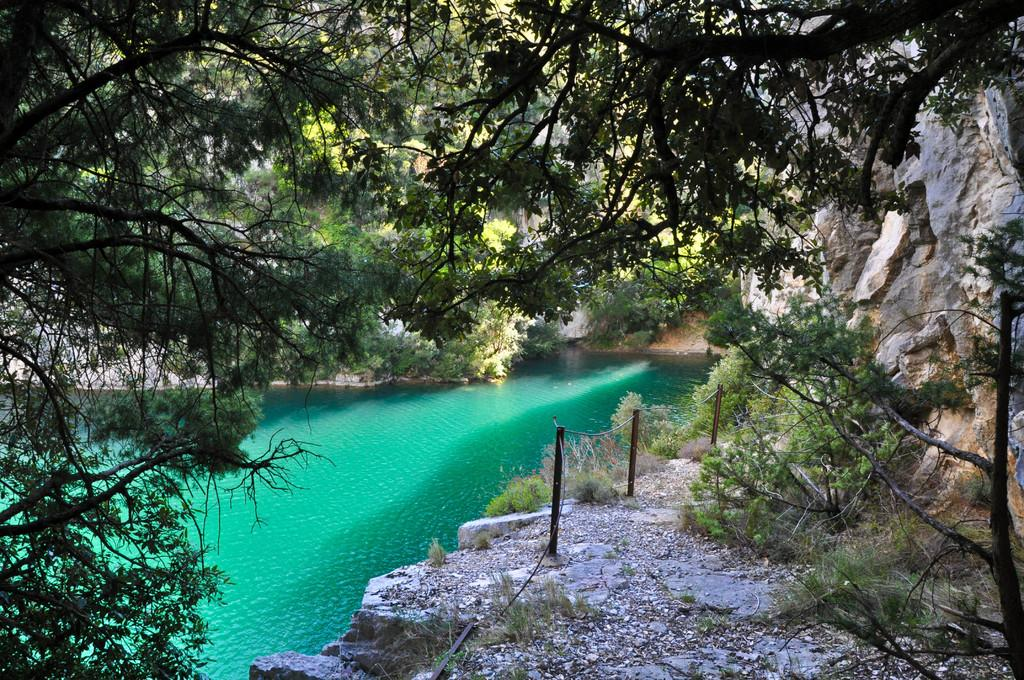What can be seen on the left side of the image? There is a pond on the left side of the image. What is located on the right side of the image? There are trees on the right side of the image. Are the trees in the water or on land? The trees are on land. What type of invention is being demonstrated in the image? There is no invention being demonstrated in the image; it features a pond and trees. What color is the flower on the left side of the image? There is no flower present in the image. 